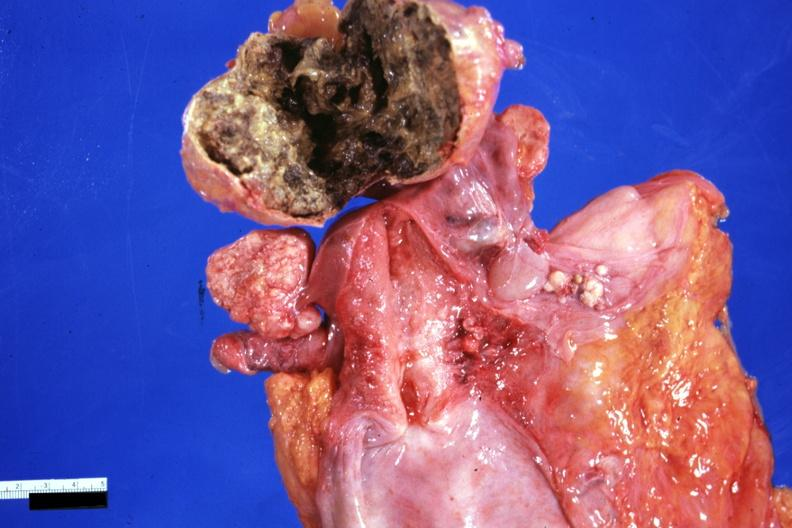s natural color present?
Answer the question using a single word or phrase. No 